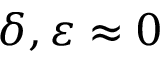<formula> <loc_0><loc_0><loc_500><loc_500>\delta , \varepsilon \approx 0</formula> 